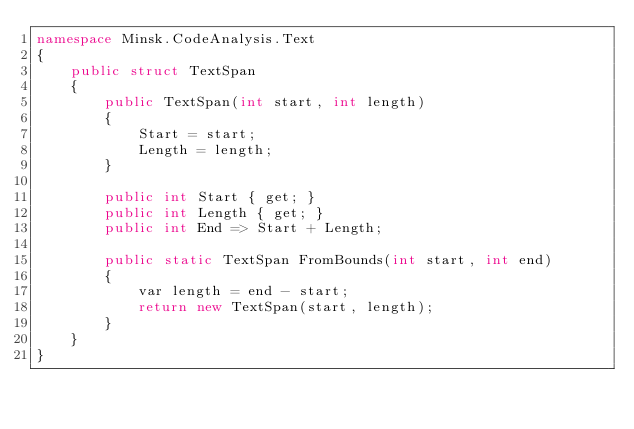Convert code to text. <code><loc_0><loc_0><loc_500><loc_500><_C#_>namespace Minsk.CodeAnalysis.Text
{
    public struct TextSpan
    {
        public TextSpan(int start, int length)
        {
            Start = start;
            Length = length;
        }

        public int Start { get; }
        public int Length { get; }
        public int End => Start + Length;

        public static TextSpan FromBounds(int start, int end)
        {
            var length = end - start;
            return new TextSpan(start, length);
        }
    }
}</code> 